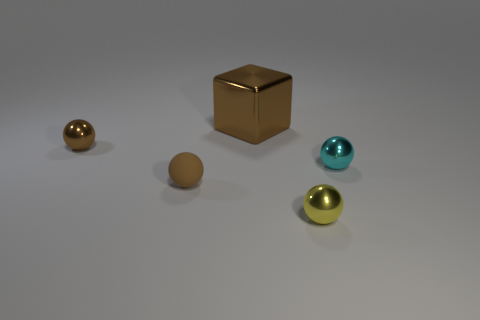Subtract all brown cylinders. How many brown spheres are left? 2 Subtract all tiny brown shiny spheres. How many spheres are left? 3 Subtract 1 balls. How many balls are left? 3 Subtract all cyan spheres. How many spheres are left? 3 Add 2 tiny matte objects. How many objects exist? 7 Subtract all balls. How many objects are left? 1 Add 2 tiny matte spheres. How many tiny matte spheres are left? 3 Add 2 large brown metal objects. How many large brown metal objects exist? 3 Subtract 0 gray balls. How many objects are left? 5 Subtract all yellow spheres. Subtract all gray cubes. How many spheres are left? 3 